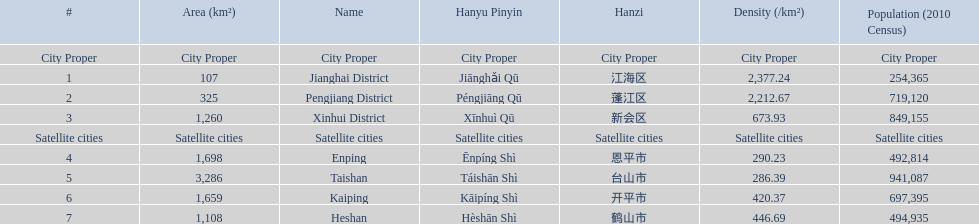What are all of the satellite cities? Enping, Taishan, Kaiping, Heshan. Of these, which has the highest population? Taishan. 